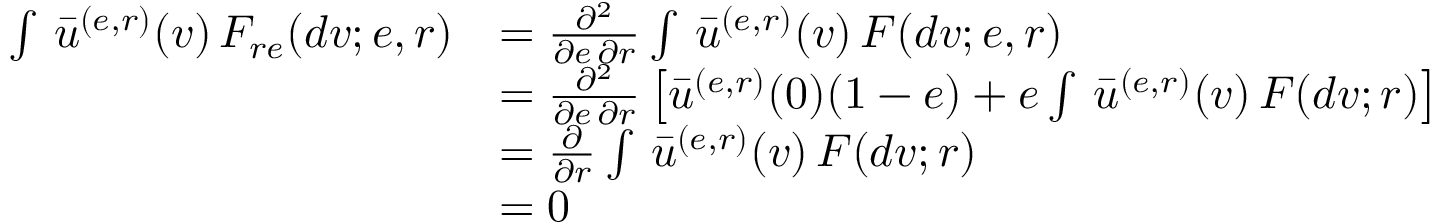Convert formula to latex. <formula><loc_0><loc_0><loc_500><loc_500>\begin{array} { r l } { \int \, \bar { u } ^ { ( e , r ) } ( v ) \, F _ { r e } ( d v ; e , r ) } & { = \frac { \partial ^ { 2 } } { \partial e \, \partial r } \int \, \bar { u } ^ { ( e , r ) } ( v ) \, F ( d v ; e , r ) } \\ & { = \frac { \partial ^ { 2 } } { \partial e \, \partial r } \left [ \bar { u } ^ { ( e , r ) } ( 0 ) ( 1 - e ) + e \int \, \bar { u } ^ { ( e , r ) } ( v ) \, F ( d v ; r ) \right ] } \\ & { = \frac { \partial } { \partial r } \int \, \bar { u } ^ { ( e , r ) } ( v ) \, F ( d v ; r ) } \\ & { = 0 } \end{array}</formula> 